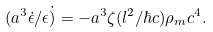Convert formula to latex. <formula><loc_0><loc_0><loc_500><loc_500>( a ^ { 3 } \dot { \epsilon } / \epsilon { \dot { ) } } = - a ^ { 3 } \zeta ( l ^ { 2 } / \hbar { c } ) \rho _ { m } c ^ { 4 } .</formula> 